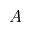<formula> <loc_0><loc_0><loc_500><loc_500>A</formula> 